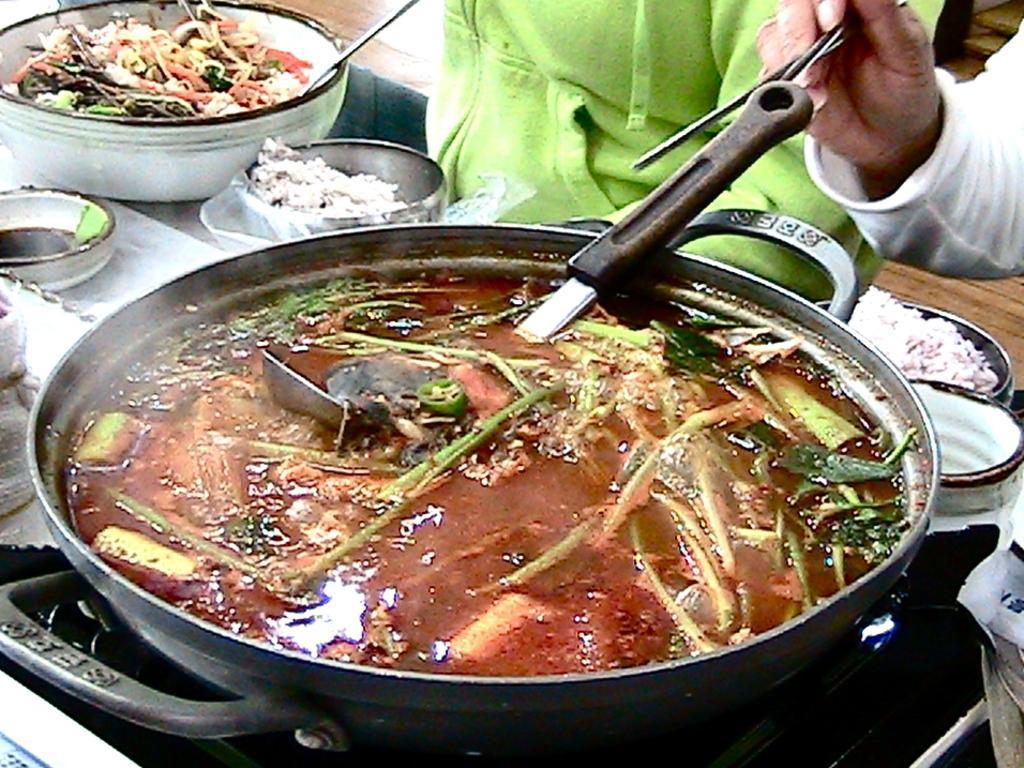Can you describe this image briefly? In this image I can see food which is in brown and green color in the bowl and I can also see a person holding few sticks. Background I can see few bowls on the table. 